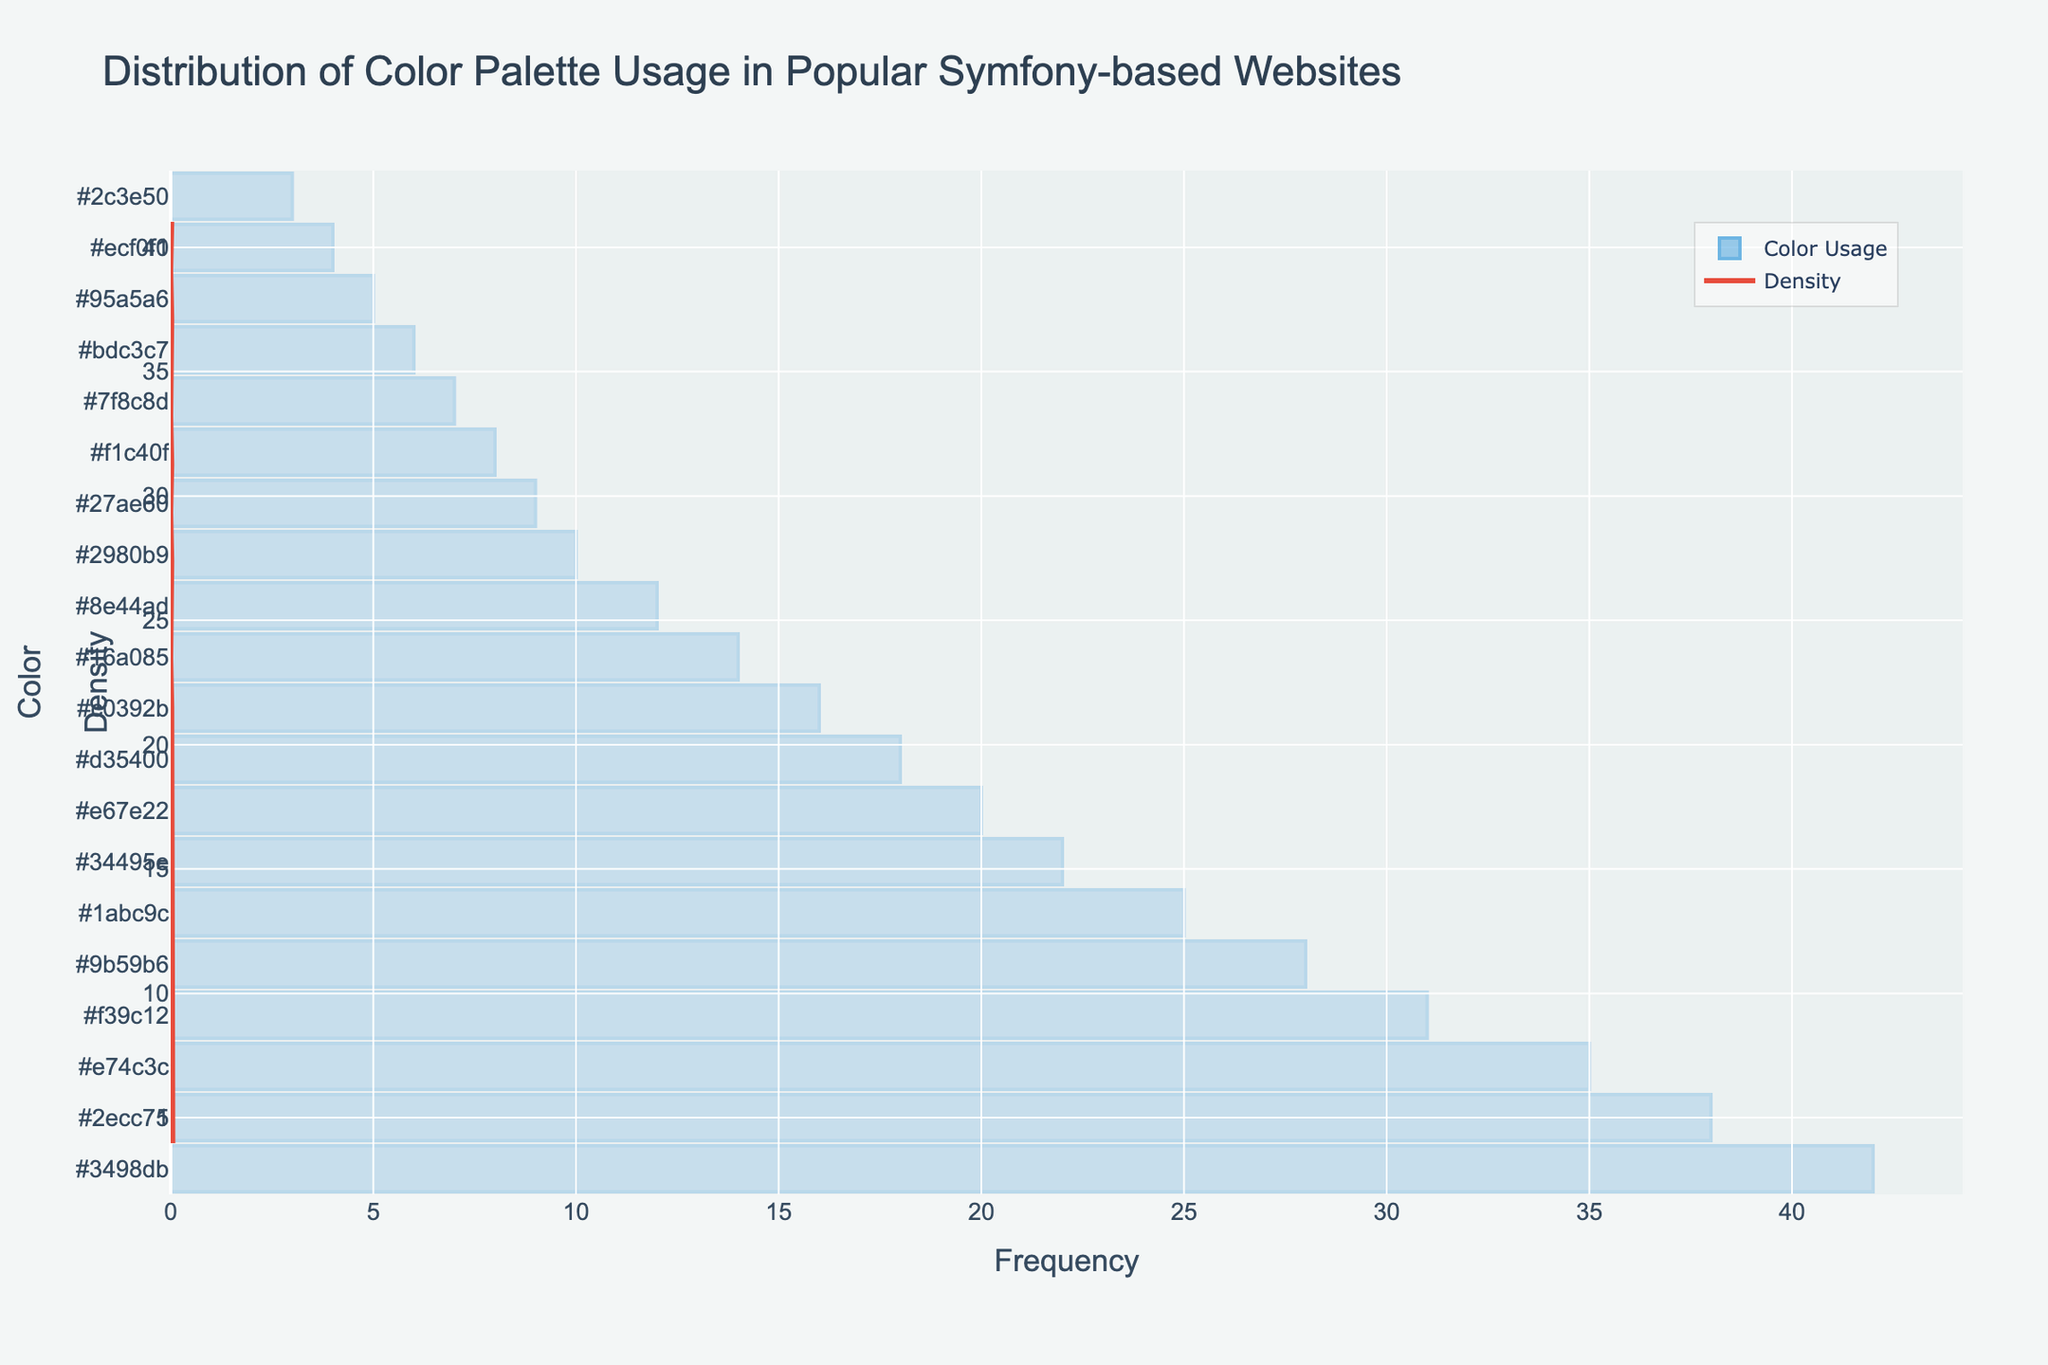What is the title of the figure? The title is located at the top of the figure and usually summarizes the content. In this case, the title clearly states "Distribution of Color Palette Usage in Popular Symfony-based Websites".
Answer: Distribution of Color Palette Usage in Popular Symfony-based Websites Which color has the highest frequency? Identify the bar that stretches the furthest to the right (highest value) on the x-axis. According to the figure, #3498db is the longest bar.
Answer: #3498db Which color has the lowest frequency? Look for the shortest bar on the x-axis, which represents the lowest frequency. In this figure, #2c3e50 has the shortest bar.
Answer: #2c3e50 How many colors have a frequency greater than 20? Count the number of bars that extend beyond the value of 20 on the x-axis. There are several such bars: #3498db, #2ecc71, #e74c3c, #f39c12, #9b59b6, and #1abc9c.
Answer: 6 What is the frequency range of the most common color? Check the x-axis value at the end of the longest bar. For #3498db, this value corresponds to 42.
Answer: 42 What does the KDE (density curve) represent in the figure? The KDE (kernel density estimate) gives a smooth approximation of the probability density function of the color usage frequency. It helps visualize the distribution more clearly than histogram bars alone.
Answer: Probability density of color usage frequencies Compare the frequencies of #16a085 and #7f8c8d. Which one is higher? Locate the bars for #16a085 and #7f8c8d and compare their lengths. #16a085 has a frequency of 14 while #7f8c8d has a frequency of 7.
Answer: #16a085 What is the median frequency of the colors? Arrange the frequencies in numerical order and find the middle value. Ordered list: 3, 4, 5, 6, 7, 8, 9, 10, 12, 14, 16, 18, 20, 22, 25, 28, 31, 35, 38, 42. The median falls between the 10th and 11th values: (14 + 16)/2 = 15.
Answer: 15 Describe any noticeable pattern in the color usage distribution. By observing both the histogram and KDE, most colors are used with frequencies clustered around 10-20, with a fewer number of colors used very frequently or very sparsely.
Answer: Most colors are used with frequencies clustered around 10-20 Which two frequencies account for the highest density in the KDE plot? Examine the KDE plot and identify the peaks in the density curve. The highest peaks correspond to frequencies 14 and 16, where the KDE curve is at its maximum.
Answer: 14 and 16 